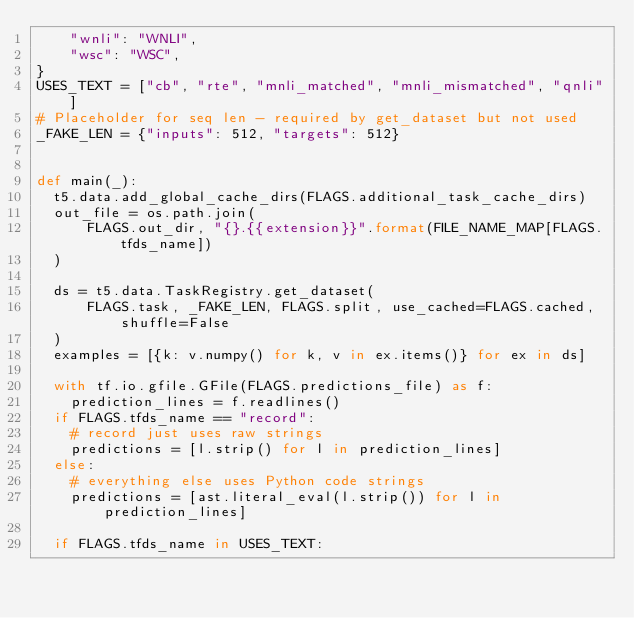<code> <loc_0><loc_0><loc_500><loc_500><_Python_>    "wnli": "WNLI",
    "wsc": "WSC",
}
USES_TEXT = ["cb", "rte", "mnli_matched", "mnli_mismatched", "qnli"]
# Placeholder for seq len - required by get_dataset but not used
_FAKE_LEN = {"inputs": 512, "targets": 512}


def main(_):
  t5.data.add_global_cache_dirs(FLAGS.additional_task_cache_dirs)
  out_file = os.path.join(
      FLAGS.out_dir, "{}.{{extension}}".format(FILE_NAME_MAP[FLAGS.tfds_name])
  )

  ds = t5.data.TaskRegistry.get_dataset(
      FLAGS.task, _FAKE_LEN, FLAGS.split, use_cached=FLAGS.cached, shuffle=False
  )
  examples = [{k: v.numpy() for k, v in ex.items()} for ex in ds]

  with tf.io.gfile.GFile(FLAGS.predictions_file) as f:
    prediction_lines = f.readlines()
  if FLAGS.tfds_name == "record":
    # record just uses raw strings
    predictions = [l.strip() for l in prediction_lines]
  else:
    # everything else uses Python code strings
    predictions = [ast.literal_eval(l.strip()) for l in prediction_lines]

  if FLAGS.tfds_name in USES_TEXT:</code> 